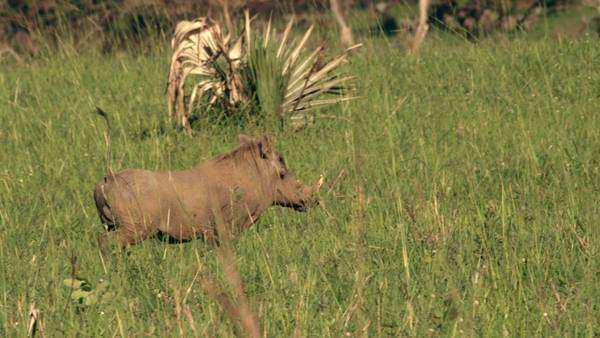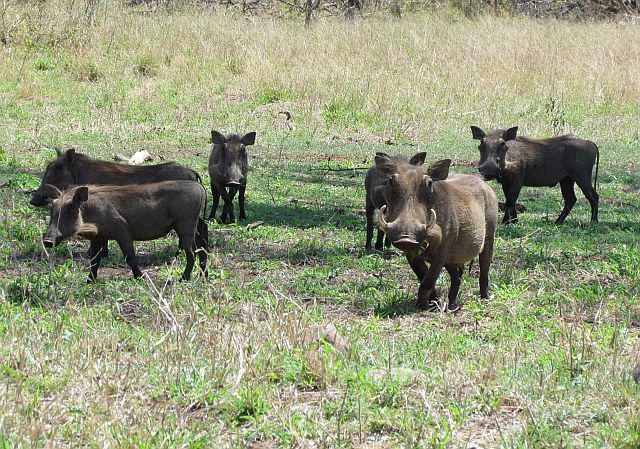The first image is the image on the left, the second image is the image on the right. Considering the images on both sides, is "There is only one wart hog in the image on the left." valid? Answer yes or no. Yes. The first image is the image on the left, the second image is the image on the right. Analyze the images presented: Is the assertion "There are 9 or more warthogs, and there are only brown ones in one of the pictures, and only black ones in the other picture." valid? Answer yes or no. No. 